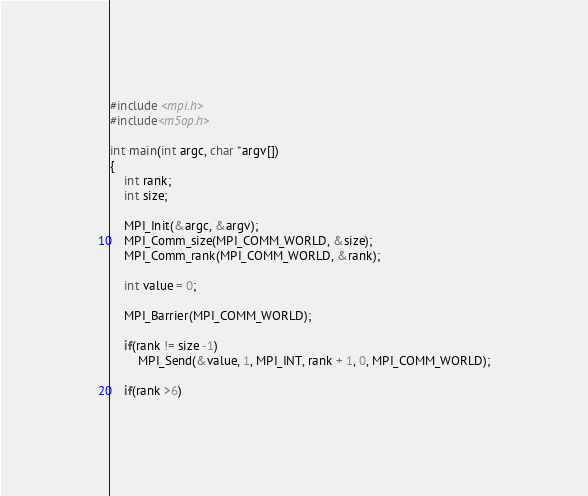<code> <loc_0><loc_0><loc_500><loc_500><_C++_>#include <mpi.h>
#include<m5op.h>

int main(int argc, char *argv[])
{
    int rank;
    int size;

    MPI_Init(&argc, &argv);
    MPI_Comm_size(MPI_COMM_WORLD, &size);
    MPI_Comm_rank(MPI_COMM_WORLD, &rank);

    int value = 0;

    MPI_Barrier(MPI_COMM_WORLD);

    if(rank != size -1)
        MPI_Send(&value, 1, MPI_INT, rank + 1, 0, MPI_COMM_WORLD);

    if(rank >6)</code> 